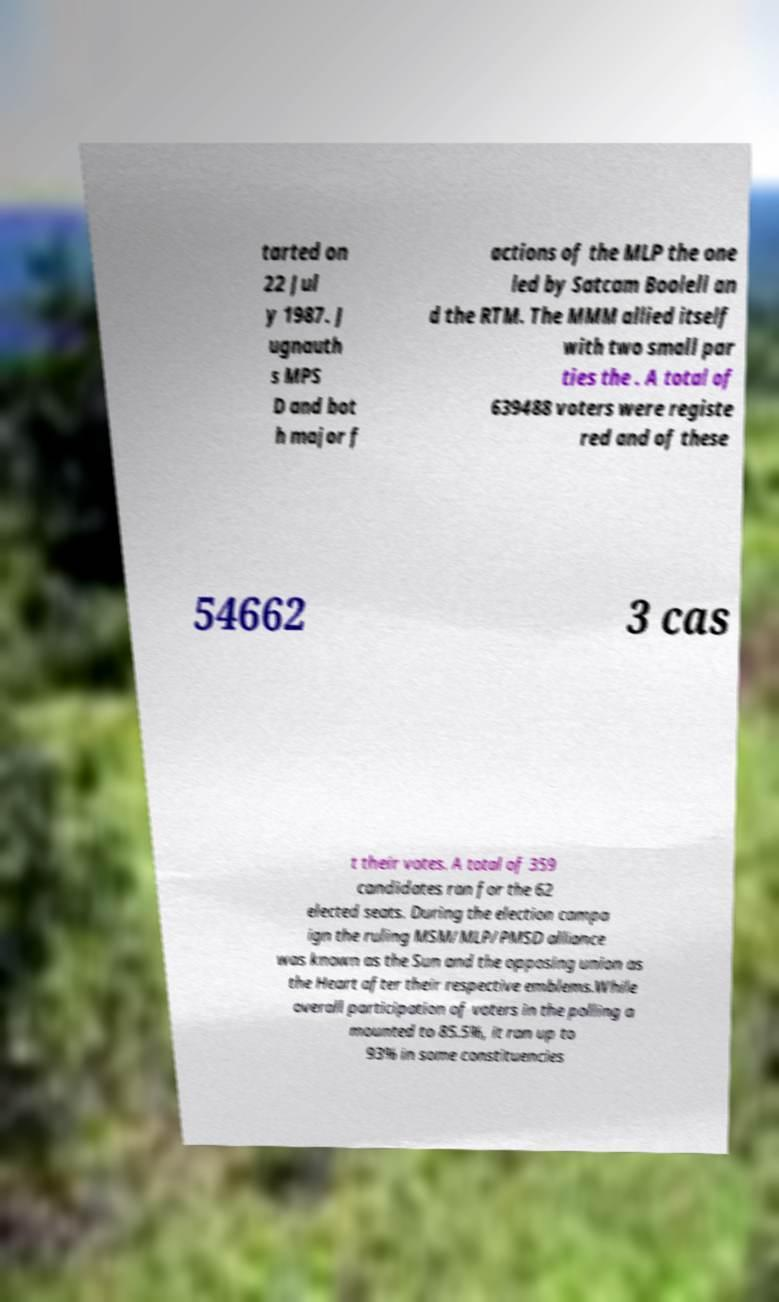Could you assist in decoding the text presented in this image and type it out clearly? tarted on 22 Jul y 1987. J ugnauth s MPS D and bot h major f actions of the MLP the one led by Satcam Boolell an d the RTM. The MMM allied itself with two small par ties the . A total of 639488 voters were registe red and of these 54662 3 cas t their votes. A total of 359 candidates ran for the 62 elected seats. During the election campa ign the ruling MSM/MLP/PMSD alliance was known as the Sun and the opposing union as the Heart after their respective emblems.While overall participation of voters in the polling a mounted to 85.5%, it ran up to 93% in some constituencies 